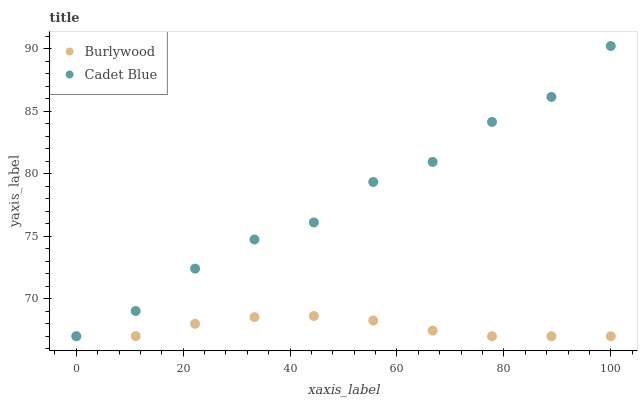Does Burlywood have the minimum area under the curve?
Answer yes or no. Yes. Does Cadet Blue have the maximum area under the curve?
Answer yes or no. Yes. Does Cadet Blue have the minimum area under the curve?
Answer yes or no. No. Is Burlywood the smoothest?
Answer yes or no. Yes. Is Cadet Blue the roughest?
Answer yes or no. Yes. Is Cadet Blue the smoothest?
Answer yes or no. No. Does Burlywood have the lowest value?
Answer yes or no. Yes. Does Cadet Blue have the highest value?
Answer yes or no. Yes. Does Cadet Blue intersect Burlywood?
Answer yes or no. Yes. Is Cadet Blue less than Burlywood?
Answer yes or no. No. Is Cadet Blue greater than Burlywood?
Answer yes or no. No. 